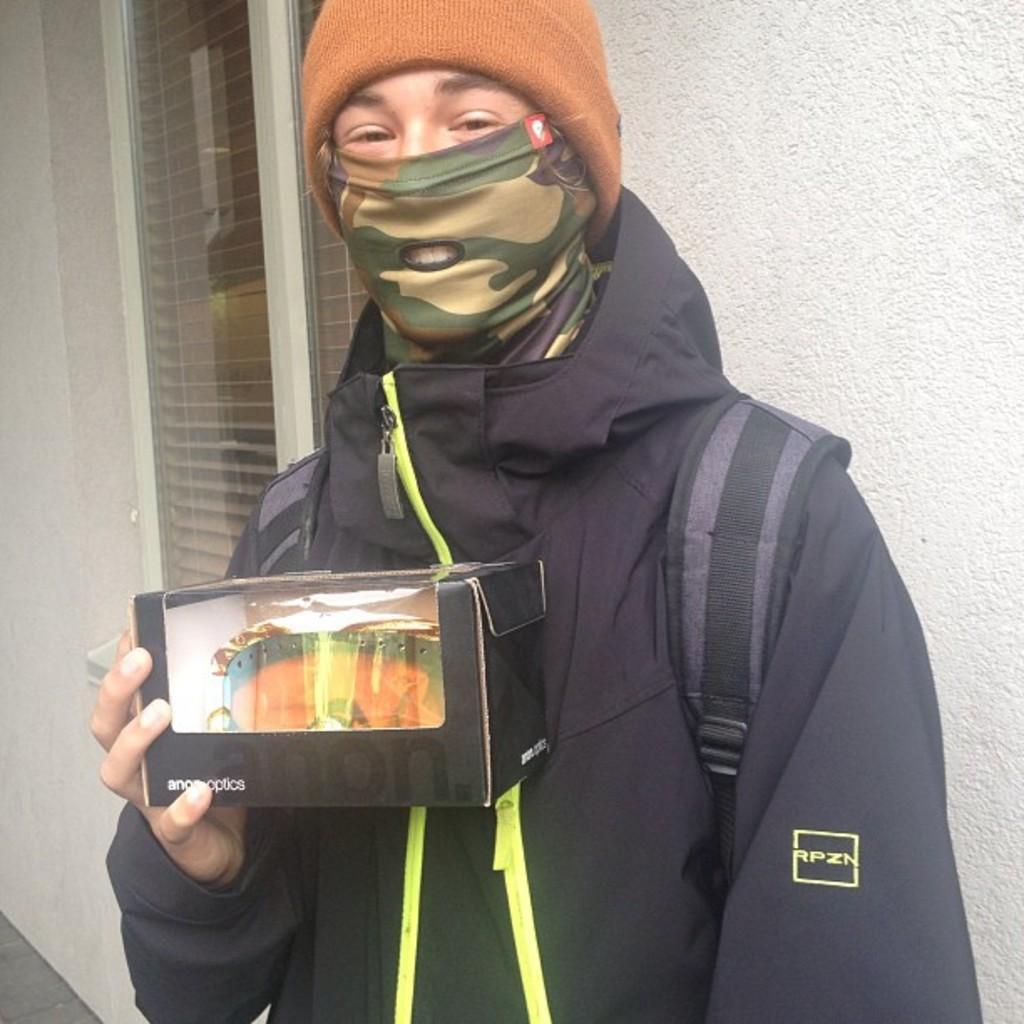How would you summarize this image in a sentence or two? In this image I can see a person is standing and wearing black color dress and holding something. Back I can see windows and the white wall. 